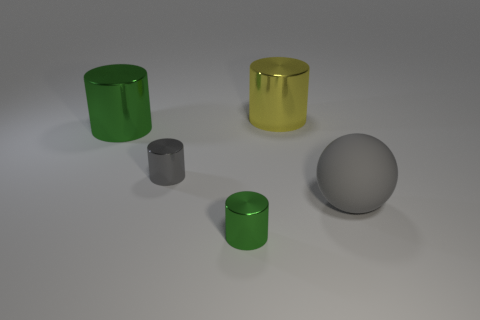Subtract all purple cylinders. Subtract all gray spheres. How many cylinders are left? 4 Add 4 small gray metal objects. How many objects exist? 9 Subtract all cylinders. How many objects are left? 1 Subtract all purple rubber spheres. Subtract all big yellow metal cylinders. How many objects are left? 4 Add 5 small green metallic objects. How many small green metallic objects are left? 6 Add 3 blue balls. How many blue balls exist? 3 Subtract 0 yellow cubes. How many objects are left? 5 